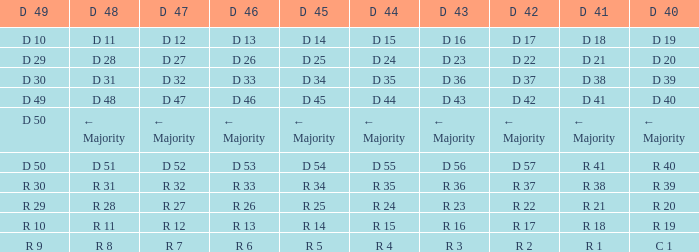I want the D 45 and D 42 of r 22 R 25. 